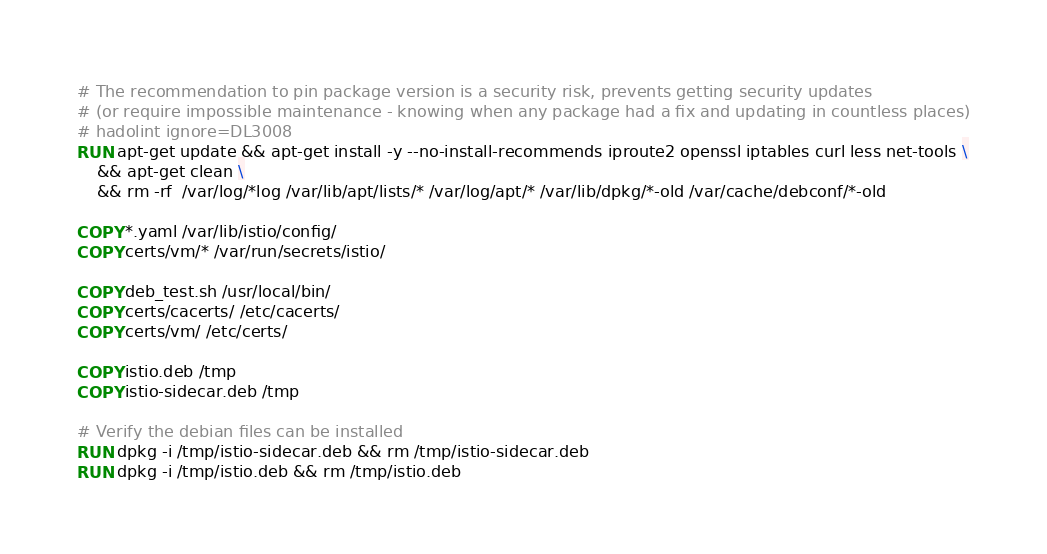Convert code to text. <code><loc_0><loc_0><loc_500><loc_500><_Dockerfile_>
# The recommendation to pin package version is a security risk, prevents getting security updates
# (or require impossible maintenance - knowing when any package had a fix and updating in countless places)
# hadolint ignore=DL3008
RUN apt-get update && apt-get install -y --no-install-recommends iproute2 openssl iptables curl less net-tools \
    && apt-get clean \
    && rm -rf  /var/log/*log /var/lib/apt/lists/* /var/log/apt/* /var/lib/dpkg/*-old /var/cache/debconf/*-old

COPY *.yaml /var/lib/istio/config/
COPY certs/vm/* /var/run/secrets/istio/

COPY deb_test.sh /usr/local/bin/
COPY certs/cacerts/ /etc/cacerts/
COPY certs/vm/ /etc/certs/

COPY istio.deb /tmp
COPY istio-sidecar.deb /tmp

# Verify the debian files can be installed
RUN dpkg -i /tmp/istio-sidecar.deb && rm /tmp/istio-sidecar.deb
RUN dpkg -i /tmp/istio.deb && rm /tmp/istio.deb

</code> 